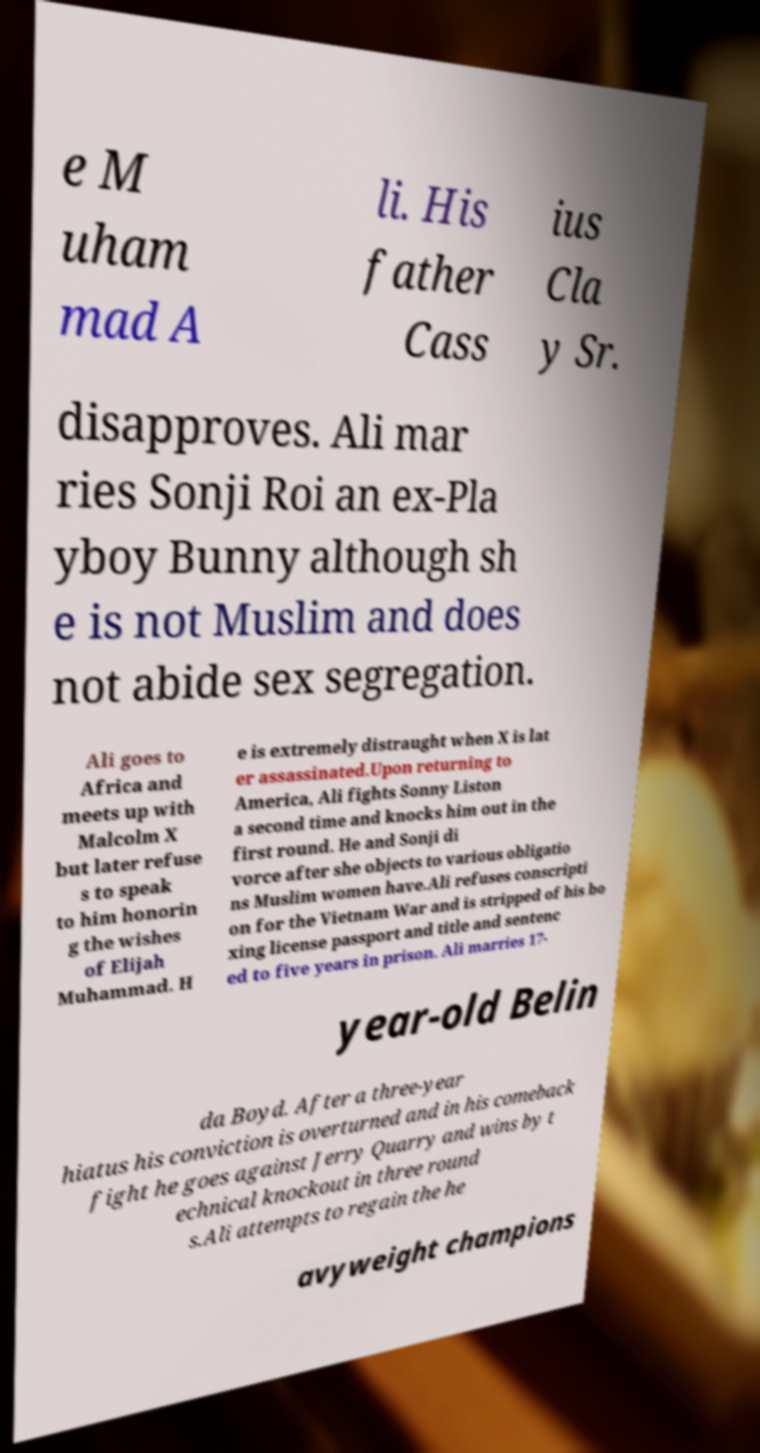Could you extract and type out the text from this image? e M uham mad A li. His father Cass ius Cla y Sr. disapproves. Ali mar ries Sonji Roi an ex-Pla yboy Bunny although sh e is not Muslim and does not abide sex segregation. Ali goes to Africa and meets up with Malcolm X but later refuse s to speak to him honorin g the wishes of Elijah Muhammad. H e is extremely distraught when X is lat er assassinated.Upon returning to America, Ali fights Sonny Liston a second time and knocks him out in the first round. He and Sonji di vorce after she objects to various obligatio ns Muslim women have.Ali refuses conscripti on for the Vietnam War and is stripped of his bo xing license passport and title and sentenc ed to five years in prison. Ali marries 17- year-old Belin da Boyd. After a three-year hiatus his conviction is overturned and in his comeback fight he goes against Jerry Quarry and wins by t echnical knockout in three round s.Ali attempts to regain the he avyweight champions 